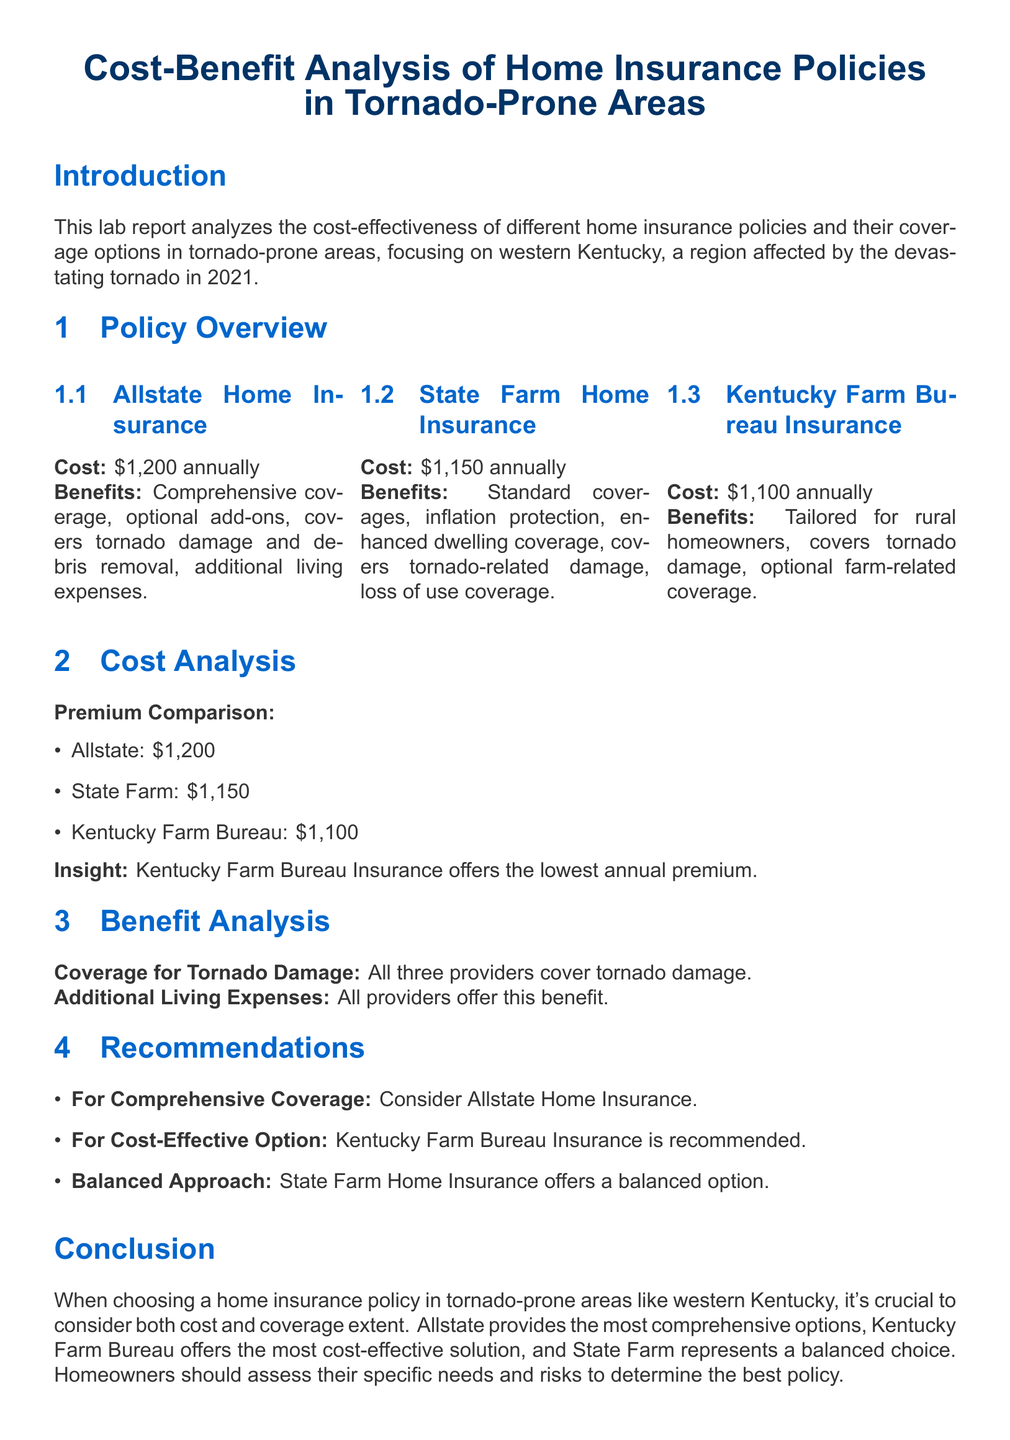What is the cost of Kentucky Farm Bureau Insurance? The cost of Kentucky Farm Bureau Insurance is listed in the Policy Overview section.
Answer: $1,100 annually What does Allstate Home Insurance cover? The coverage details for Allstate Home Insurance are specified in the Policy Overview section, highlighting the benefits.
Answer: Comprehensive coverage, optional add-ons, covers tornado damage and debris removal, additional living expenses Which insurance provider offers the highest premium? The premium comparison lists the costs of all providers, allowing for easy identification of the highest amount.
Answer: Allstate What is the recommended option for cost-effectiveness? The Recommendations section suggests the most cost-effective solution based on the analysis presented.
Answer: Kentucky Farm Bureau Insurance Which insurance policy provides inflation protection? The specific benefits of State Farm Home Insurance include inflation protection as mentioned in the overview.
Answer: State Farm Home Insurance What do all providers offer in terms of tornado coverage? The Benefit Analysis section indicates that all three insurance providers cover tornado-related damage.
Answer: Coverage for tornado damage Which company provides a balanced option according to the report? The Recommendations section highlights which provider is considered a balanced choice for homeowners.
Answer: State Farm Home Insurance 